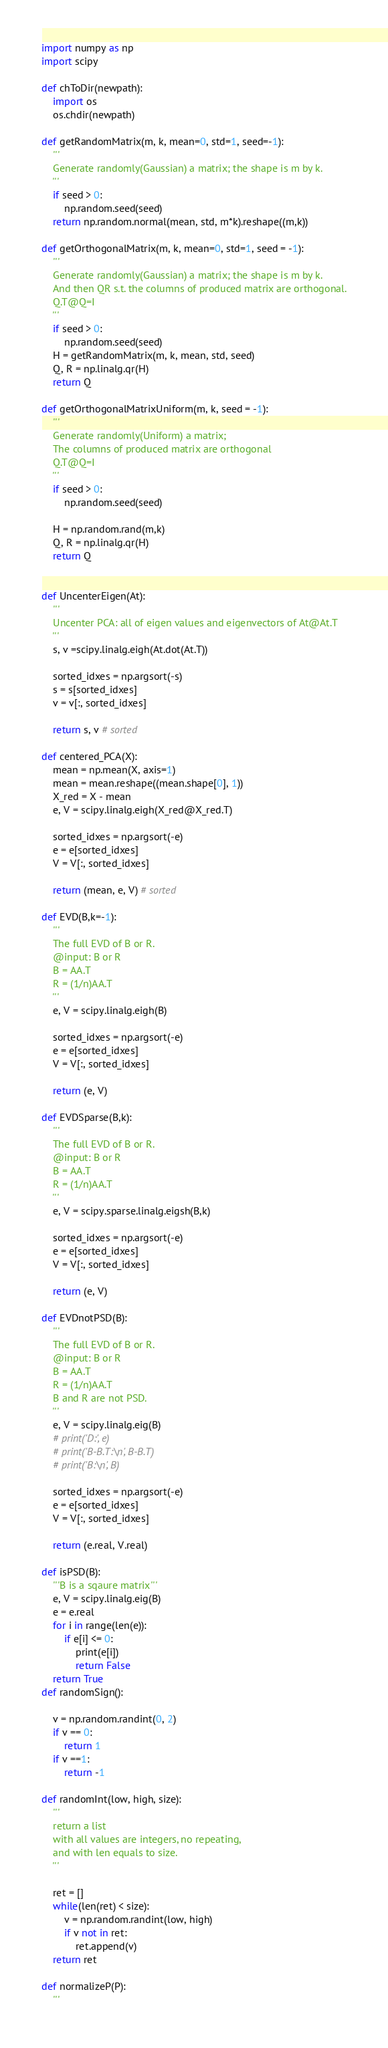Convert code to text. <code><loc_0><loc_0><loc_500><loc_500><_Python_>
import numpy as np
import scipy

def chToDir(newpath):
    import os
    os.chdir(newpath)

def getRandomMatrix(m, k, mean=0, std=1, seed=-1):
    '''
    Generate randomly(Gaussian) a matrix; the shape is m by k.
    '''
    if seed > 0:
        np.random.seed(seed)
    return np.random.normal(mean, std, m*k).reshape((m,k))

def getOrthogonalMatrix(m, k, mean=0, std=1, seed = -1):
    '''
    Generate randomly(Gaussian) a matrix; the shape is m by k.
    And then QR s.t. the columns of produced matrix are orthogonal.
    Q.T@Q=I
    '''
    if seed > 0:
        np.random.seed(seed)
    H = getRandomMatrix(m, k, mean, std, seed)
    Q, R = np.linalg.qr(H)
    return Q

def getOrthogonalMatrixUniform(m, k, seed = -1):
    '''
    Generate randomly(Uniform) a matrix;
    The columns of produced matrix are orthogonal
    Q.T@Q=I
    '''
    if seed > 0:
        np.random.seed(seed)
        
    H = np.random.rand(m,k)
    Q, R = np.linalg.qr(H)
    return Q
    

def UncenterEigen(At):
    '''
    Uncenter PCA: all of eigen values and eigenvectors of At@At.T
    ''' 
    s, v =scipy.linalg.eigh(At.dot(At.T))

    sorted_idxes = np.argsort(-s)
    s = s[sorted_idxes]
    v = v[:, sorted_idxes]
        
    return s, v # sorted

def centered_PCA(X):
    mean = np.mean(X, axis=1)
    mean = mean.reshape((mean.shape[0], 1))
    X_red = X - mean
    e, V = scipy.linalg.eigh(X_red@X_red.T)

    sorted_idxes = np.argsort(-e)
    e = e[sorted_idxes]
    V = V[:, sorted_idxes]

    return (mean, e, V) # sorted

def EVD(B,k=-1):
    '''
    The full EVD of B or R.
    @input: B or R
    B = AA.T
    R = (1/n)AA.T
    '''
    e, V = scipy.linalg.eigh(B)

    sorted_idxes = np.argsort(-e)
    e = e[sorted_idxes]
    V = V[:, sorted_idxes]

    return (e, V)

def EVDSparse(B,k):
    '''
    The full EVD of B or R.
    @input: B or R
    B = AA.T
    R = (1/n)AA.T
    '''
    e, V = scipy.sparse.linalg.eigsh(B,k)

    sorted_idxes = np.argsort(-e)
    e = e[sorted_idxes]
    V = V[:, sorted_idxes]

    return (e, V)

def EVDnotPSD(B):
    '''
    The full EVD of B or R.
    @input: B or R
    B = AA.T
    R = (1/n)AA.T
    B and R are not PSD.
    '''
    e, V = scipy.linalg.eig(B)
    # print('D:', e)
    # print('B-B.T:\n', B-B.T)
    # print('B:\n', B)

    sorted_idxes = np.argsort(-e)
    e = e[sorted_idxes]
    V = V[:, sorted_idxes]

    return (e.real, V.real)

def isPSD(B):
    '''B is a sqaure matrix'''
    e, V = scipy.linalg.eig(B)
    e = e.real
    for i in range(len(e)):
        if e[i] <= 0:
            print(e[i])
            return False
    return True
def randomSign():

    v = np.random.randint(0, 2)
    if v == 0:
        return 1
    if v ==1:
        return -1

def randomInt(low, high, size):
    '''
    return a list 
    with all values are integers, no repeating, 
    and with len equals to size.
    '''

    ret = []
    while(len(ret) < size):
        v = np.random.randint(low, high)
        if v not in ret:
            ret.append(v)
    return ret

def normalizeP(P):
    '''</code> 